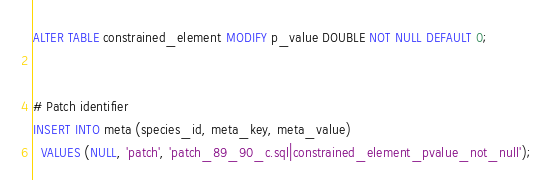Convert code to text. <code><loc_0><loc_0><loc_500><loc_500><_SQL_>ALTER TABLE constrained_element MODIFY p_value DOUBLE NOT NULL DEFAULT 0;


# Patch identifier
INSERT INTO meta (species_id, meta_key, meta_value)
  VALUES (NULL, 'patch', 'patch_89_90_c.sql|constrained_element_pvalue_not_null');
</code> 